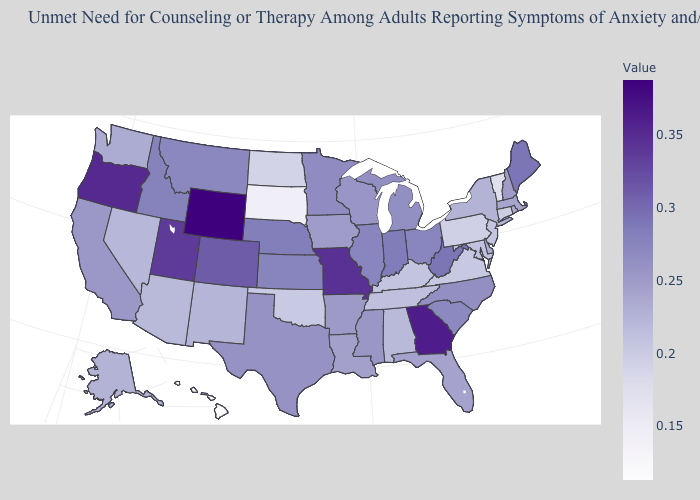Among the states that border Rhode Island , does Connecticut have the lowest value?
Quick response, please. Yes. Which states have the lowest value in the USA?
Give a very brief answer. Hawaii. Which states have the highest value in the USA?
Keep it brief. Wyoming. Which states have the lowest value in the Northeast?
Keep it brief. Vermont. Which states hav the highest value in the West?
Short answer required. Wyoming. Among the states that border Arkansas , which have the lowest value?
Be succinct. Oklahoma. 